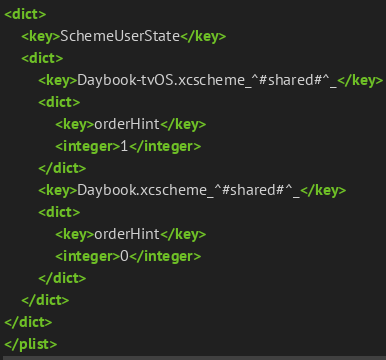Convert code to text. <code><loc_0><loc_0><loc_500><loc_500><_XML_><dict>
	<key>SchemeUserState</key>
	<dict>
		<key>Daybook-tvOS.xcscheme_^#shared#^_</key>
		<dict>
			<key>orderHint</key>
			<integer>1</integer>
		</dict>
		<key>Daybook.xcscheme_^#shared#^_</key>
		<dict>
			<key>orderHint</key>
			<integer>0</integer>
		</dict>
	</dict>
</dict>
</plist>
</code> 